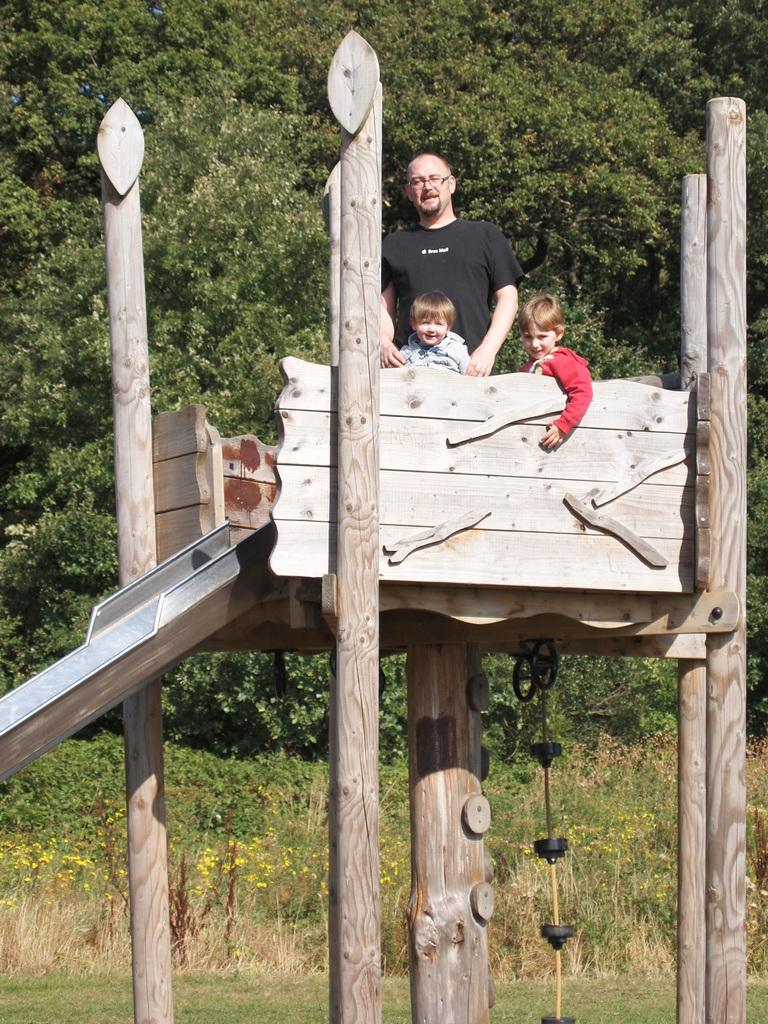Who is present in the image besides the kids? There is a man in the image. Where are the man and kids located in the image? The man and kids are on top of a slide. What is the slide made of? The slide is made of wooden sticks and a metal sheet. What can be seen in the background of the image? There are trees in the background of the image. When is the birthday of the man in the image? The provided facts do not mention the man's birthday, so we cannot determine when it is. How many cherries are on the slide in the image? There are no cherries present in the image; the slide is made of wooden sticks and a metal sheet. 